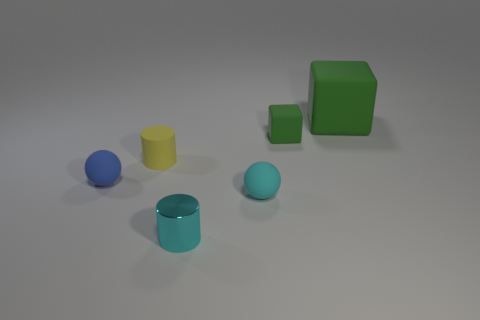Add 4 gray objects. How many objects exist? 10 Subtract all blocks. How many objects are left? 4 Subtract 0 brown cylinders. How many objects are left? 6 Subtract all large cyan metal cubes. Subtract all yellow rubber cylinders. How many objects are left? 5 Add 4 green matte cubes. How many green matte cubes are left? 6 Add 3 large green rubber blocks. How many large green rubber blocks exist? 4 